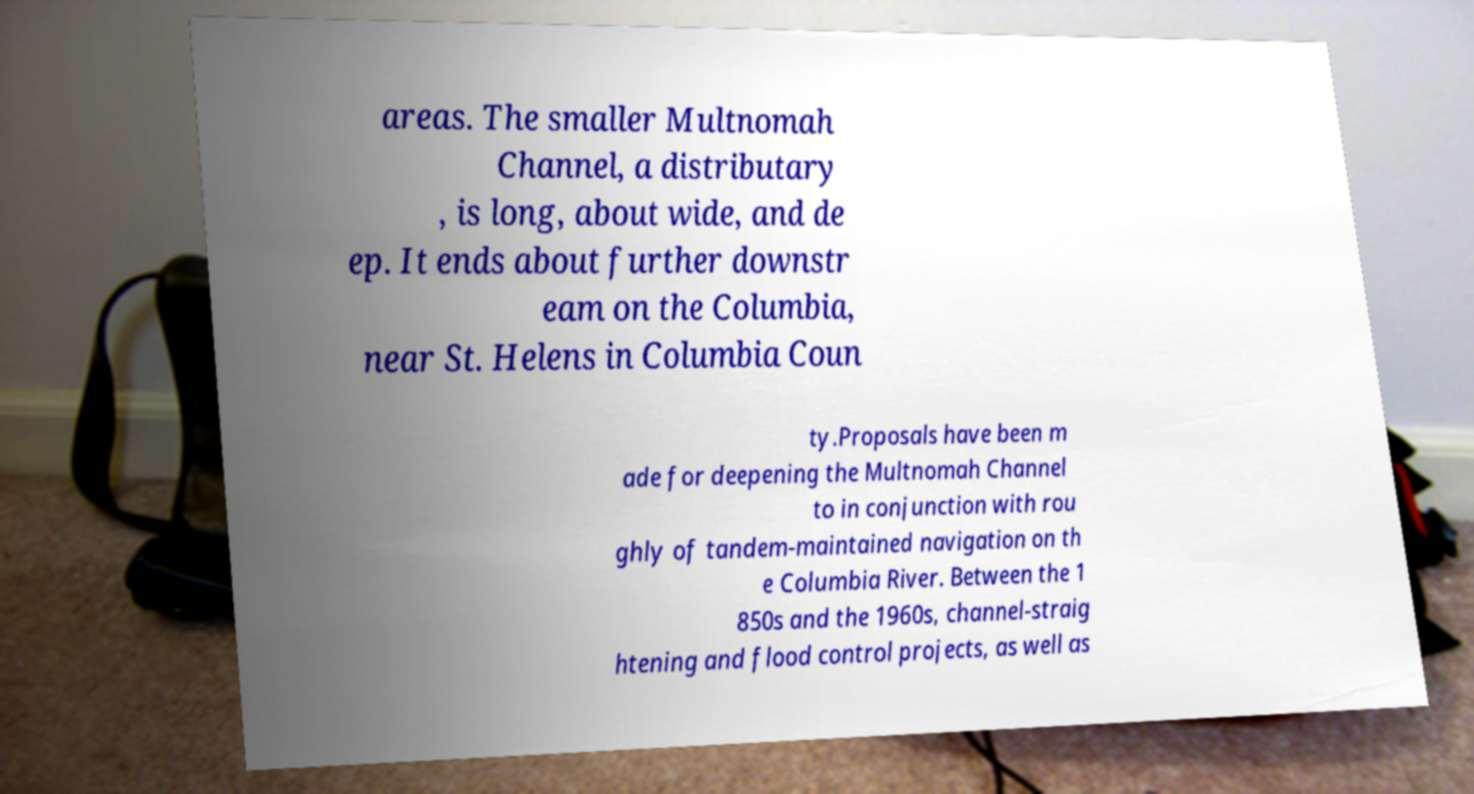Can you accurately transcribe the text from the provided image for me? areas. The smaller Multnomah Channel, a distributary , is long, about wide, and de ep. It ends about further downstr eam on the Columbia, near St. Helens in Columbia Coun ty.Proposals have been m ade for deepening the Multnomah Channel to in conjunction with rou ghly of tandem-maintained navigation on th e Columbia River. Between the 1 850s and the 1960s, channel-straig htening and flood control projects, as well as 